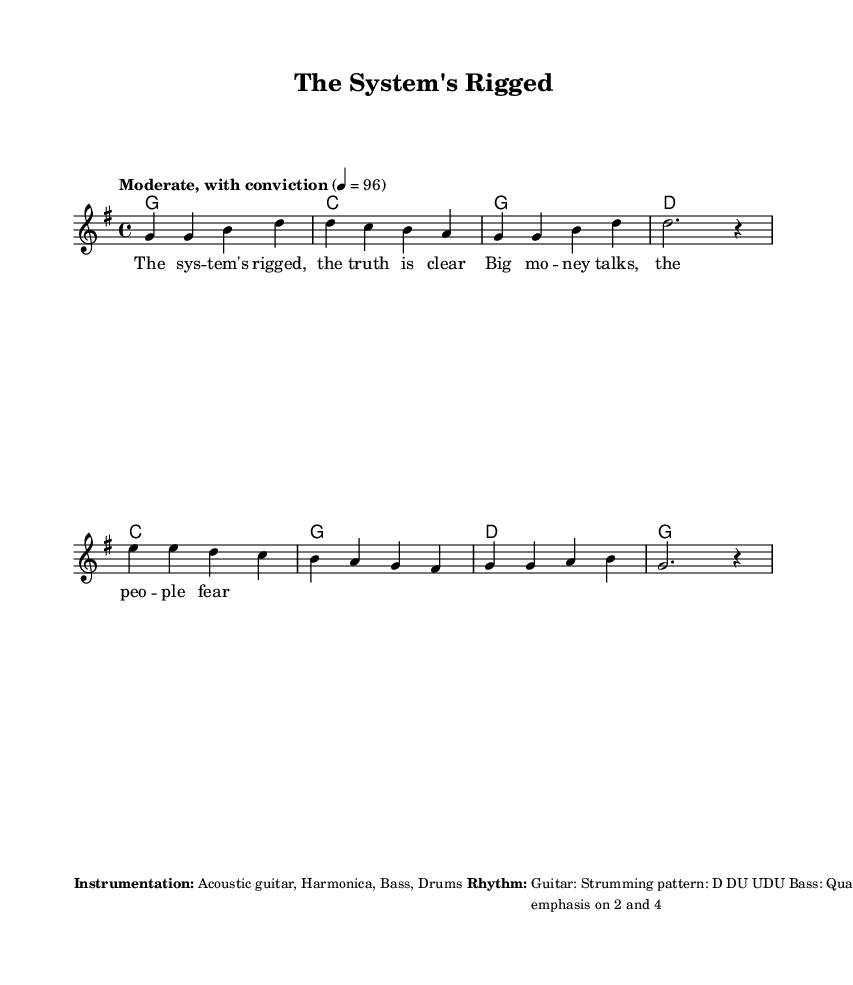What is the key signature of this music? The key signature indicates the presence of one sharp (F#), which designates this piece as being in the key of G major.
Answer: G major What is the time signature of this music? The time signature at the beginning of the score is 4/4, meaning there are four beats in each measure and the quarter note gets one beat.
Answer: 4/4 What is the tempo marking of this piece? The tempo marking in the score states "Moderate, with conviction," indicating a moderate pace at a speed of 96 beats per minute.
Answer: Moderate, with conviction How many verses does the song have? By examining the song structure presented, we see there are at least two verses indicated before the chorus, thus the song has two verses.
Answer: Two What instruments are used in this piece? The instrumentation listed includes Acoustic guitar, Harmonica, Bass, and Drums; each contributes to the overall sound of the song.
Answer: Acoustic guitar, Harmonica, Bass, Drums What strumming pattern is specified for the guitar? The chord section indicates a strumming pattern of D DU UDU, where "D" represents down strums and "U" up strums, providing a rhythmic characteristic to the piece.
Answer: D DU UDU What type of beat do the drums emphasize? The additional notes mention that the drums use a basic rock beat with an emphasis on beats 2 and 4, which is common in rock music to create a strong backbeat.
Answer: 2 and 4 